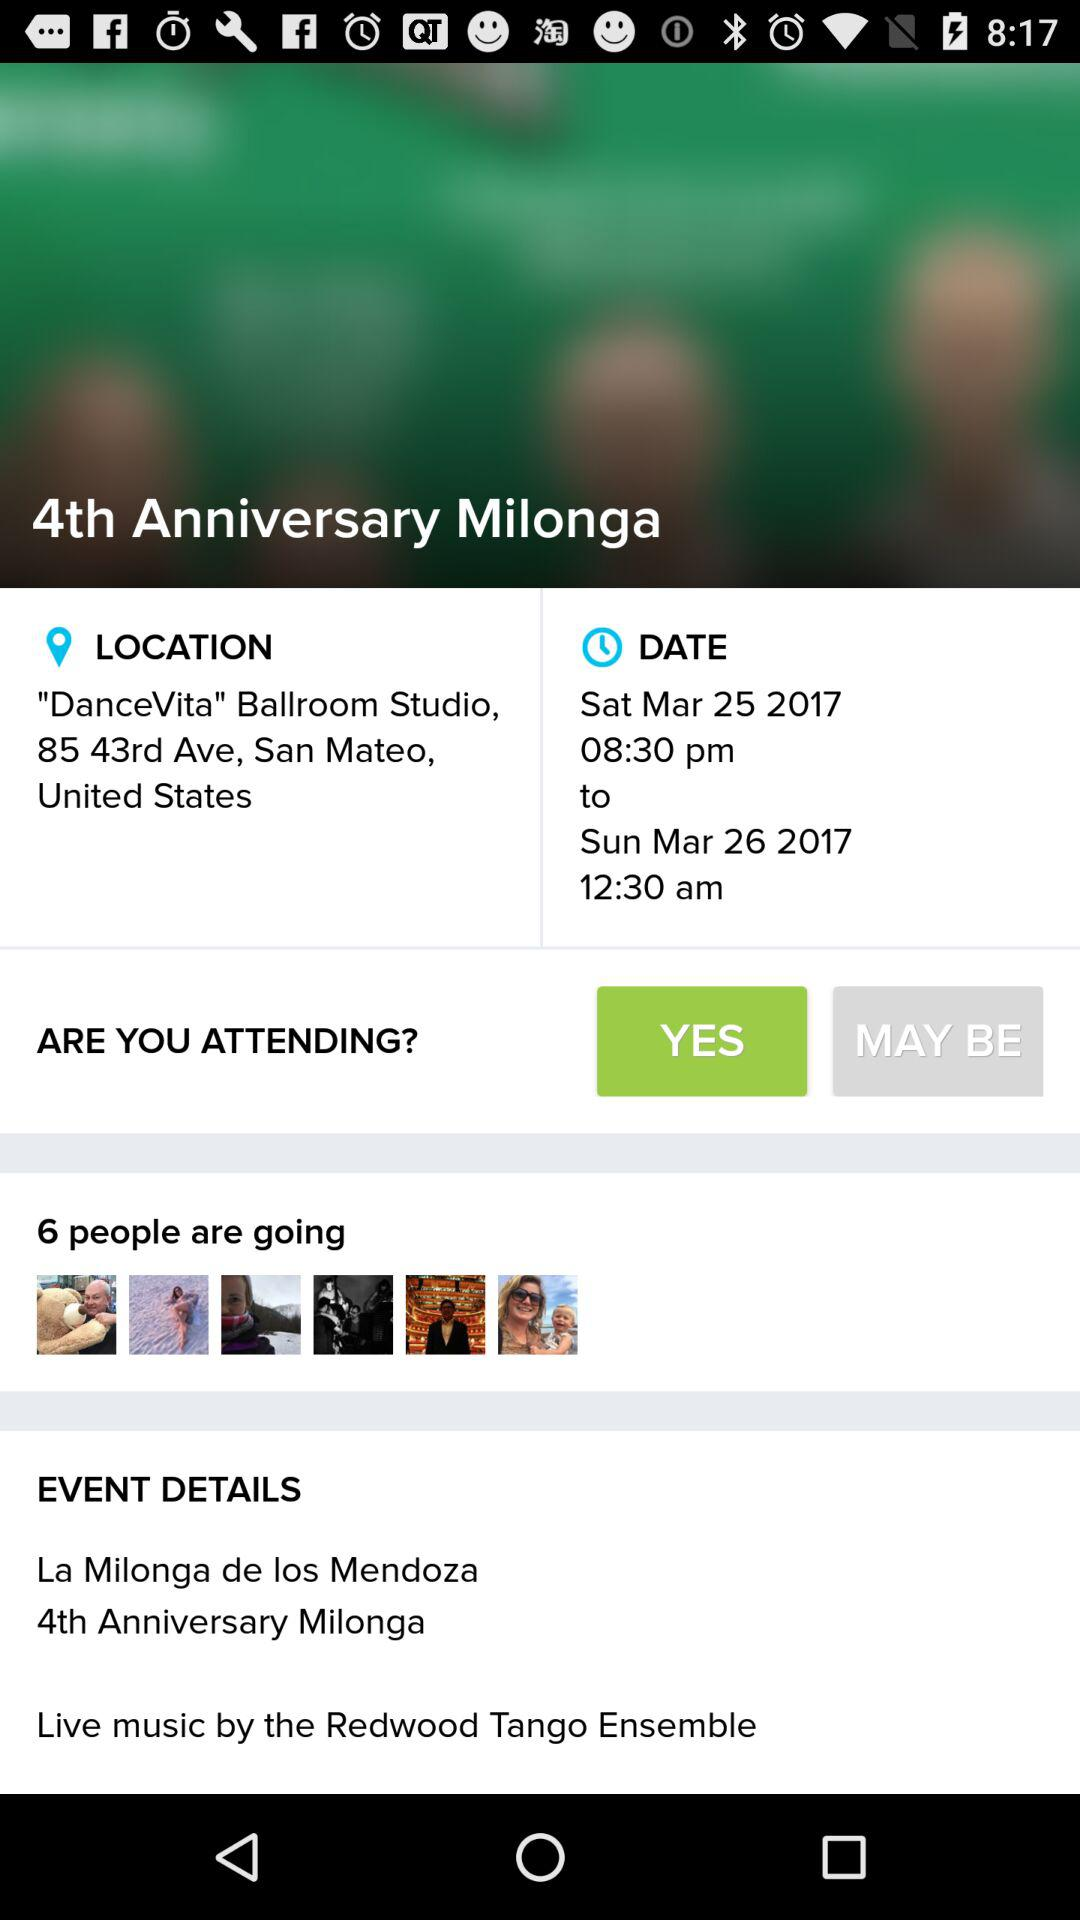What is the date of the event?
Answer the question using a single word or phrase. Sun Apr 02 2017 